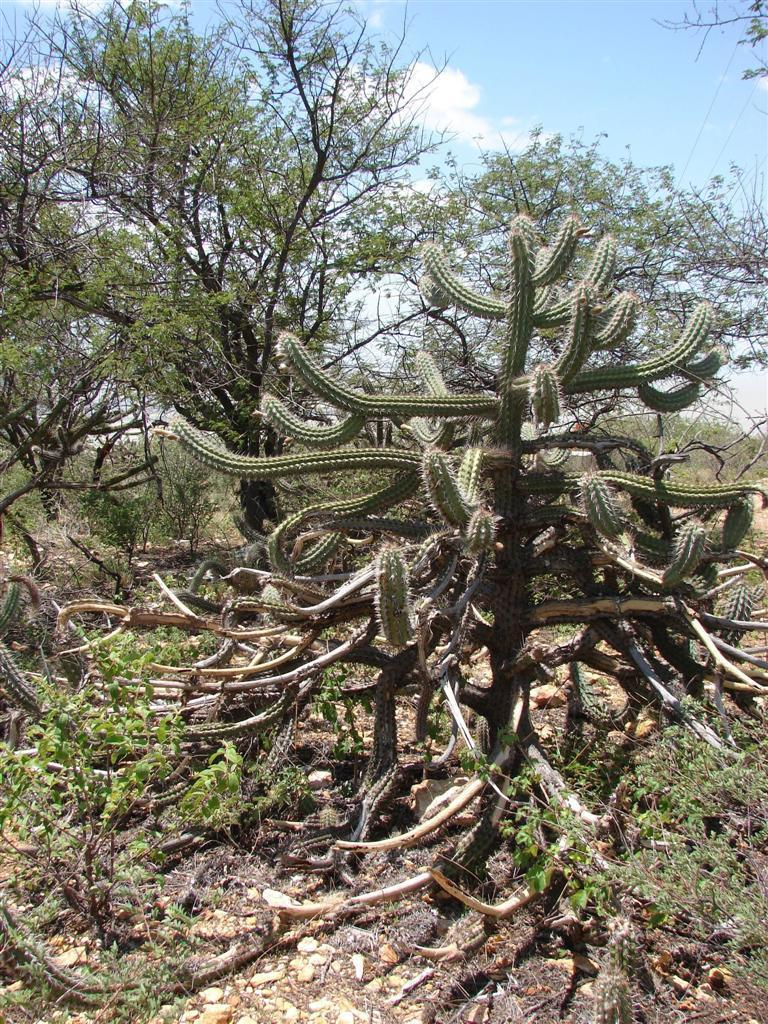What type of vegetation can be seen in the image? There are plants and trees in the image. What is visible at the top of the image? The sky is visible at the top of the image. What color is the sweater hanging on the shelf in the image? There is no sweater or shelf present in the image; it features plants, trees, and the sky. What type of fruit is hanging from the trees in the image? There is no fruit visible on the trees in the image; only the plants, trees, and sky are present. 